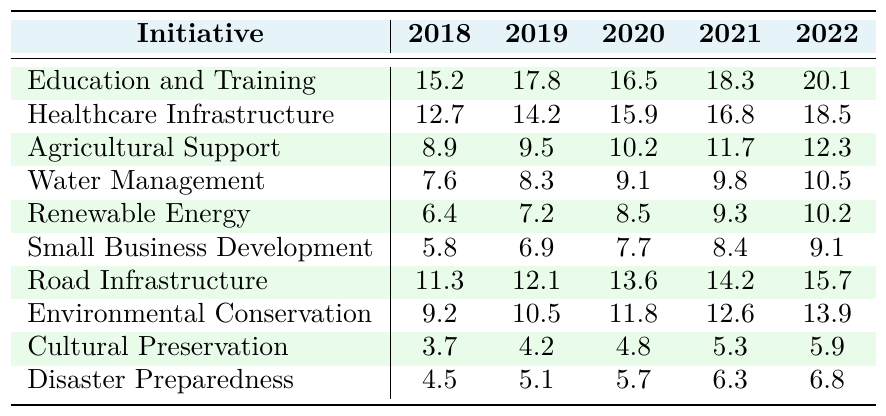What was the highest amount allocated to any initiative in 2022? The allocations in 2022 are: Education and Training (20.1), Healthcare Infrastructure (18.5), Agricultural Support (12.3), Water Management (10.5), Renewable Energy (10.2), Small Business Development (9.1), Road Infrastructure (15.7), Environmental Conservation (13.9), Cultural Preservation (5.9), Disaster Preparedness (6.8). The highest value is 20.1 for Education and Training.
Answer: 20.1 Which two initiatives saw the largest increase in funding from 2021 to 2022? The increases from 2021 to 2022 are: Education and Training (20.1 - 18.3 = 1.8), Healthcare Infrastructure (18.5 - 16.8 = 1.7), Agricultural Support (12.3 - 11.7 = 0.6), Water Management (10.5 - 9.8 = 0.7), Renewable Energy (10.2 - 9.3 = 0.9), Small Business Development (9.1 - 8.4 = 0.7), Road Infrastructure (15.7 - 14.2 = 1.5), Environmental Conservation (13.9 - 12.6 = 1.3), Cultural Preservation (5.9 - 5.3 = 0.6), Disaster Preparedness (6.8 - 6.3 = 0.5). The largest increases are in Education and Training (1.8) and Healthcare Infrastructure (1.7).
Answer: Education and Training, Healthcare Infrastructure What was the total funding allocated to agricultural support from 2018 to 2022? The allocations for Agricultural Support from 2018 to 2022 are: 8.9 + 9.5 + 10.2 + 11.7 + 12.3 = 52.6. Adding these values together gives a total of 52.6.
Answer: 52.6 Did any initiative receive less than 10 in 2019? The allocations in 2019 are: Education and Training (17.8), Healthcare Infrastructure (14.2), Agricultural Support (9.5), Water Management (8.3), Renewable Energy (7.2), Small Business Development (6.9), Road Infrastructure (12.1), Environmental Conservation (10.5), Cultural Preservation (4.2), Disaster Preparedness (5.1). The values less than 10 are from Water Management, Renewable Energy, Small Business Development, Cultural Preservation, and Disaster Preparedness. Therefore, the answer is yes.
Answer: Yes Which initiative experienced the most consistent funding over the years? We compare the yearly allocations for all initiatives: Education and Training increases steadily, Healthcare also shows a steady increase, Agricultural Support shows a gradual increase but not as steep, others like Small Business Development show smaller increases. We can observe that Water Management has a consistent but lower growth pattern, while Environmental Conservation has slight variation too. Overall, Healthcare Infrastructure shows steady and consistent growth each year.
Answer: Healthcare Infrastructure What was the average funding amount for Road Infrastructure over the years? The allocations for Road Infrastructure are: 11.3 + 12.1 + 13.6 + 14.2 + 15.7 = 66.9. The average is calculated as 66.9 / 5 = 13.38.
Answer: 13.38 Was there any year where the total funding for Cultural Preservation and Disaster Preparedness was more than for Water Management? Calculate the combined values for Cultural Preservation and Disaster Preparedness: Cultural Preservation + Disaster Preparedness = (3.7 + 4.5), (4.2 + 5.1), (4.8 + 5.7), (5.3 + 6.3), (5.9 + 6.8) for each year respectively. The total for Water Management are: 7.6, 8.3, 9.1, 9.8, 10.5. These two initiatives combined exceed Water Management funding in years 2018 and 2019. Therefore, yes, there are these years.
Answer: Yes What initiative had the lowest allocation in 2020? The allocations in 2020 are: Education and Training (16.5), Healthcare Infrastructure (15.9), Agricultural Support (10.2), Water Management (9.1), Renewable Energy (8.5), Small Business Development (7.7), Road Infrastructure (13.6), Environmental Conservation (11.8), Cultural Preservation (4.8), Disaster Preparedness (5.7). The lowest allocation in 2020 is for Small Business Development at 7.7.
Answer: Small Business Development 